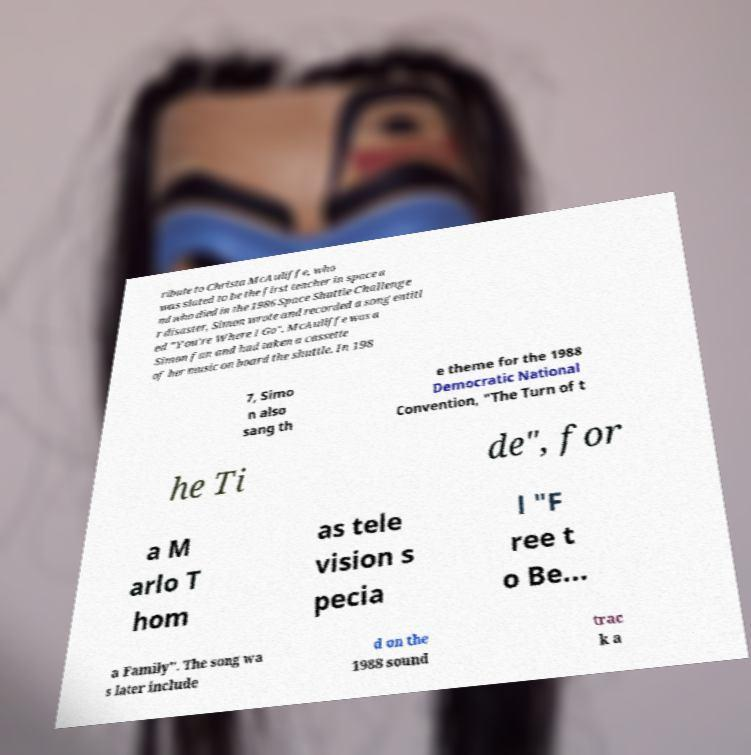Can you read and provide the text displayed in the image?This photo seems to have some interesting text. Can you extract and type it out for me? ribute to Christa McAuliffe, who was slated to be the first teacher in space a nd who died in the 1986 Space Shuttle Challenge r disaster, Simon wrote and recorded a song entitl ed "You're Where I Go". McAuliffe was a Simon fan and had taken a cassette of her music on board the shuttle. In 198 7, Simo n also sang th e theme for the 1988 Democratic National Convention, "The Turn of t he Ti de", for a M arlo T hom as tele vision s pecia l "F ree t o Be... a Family". The song wa s later include d on the 1988 sound trac k a 